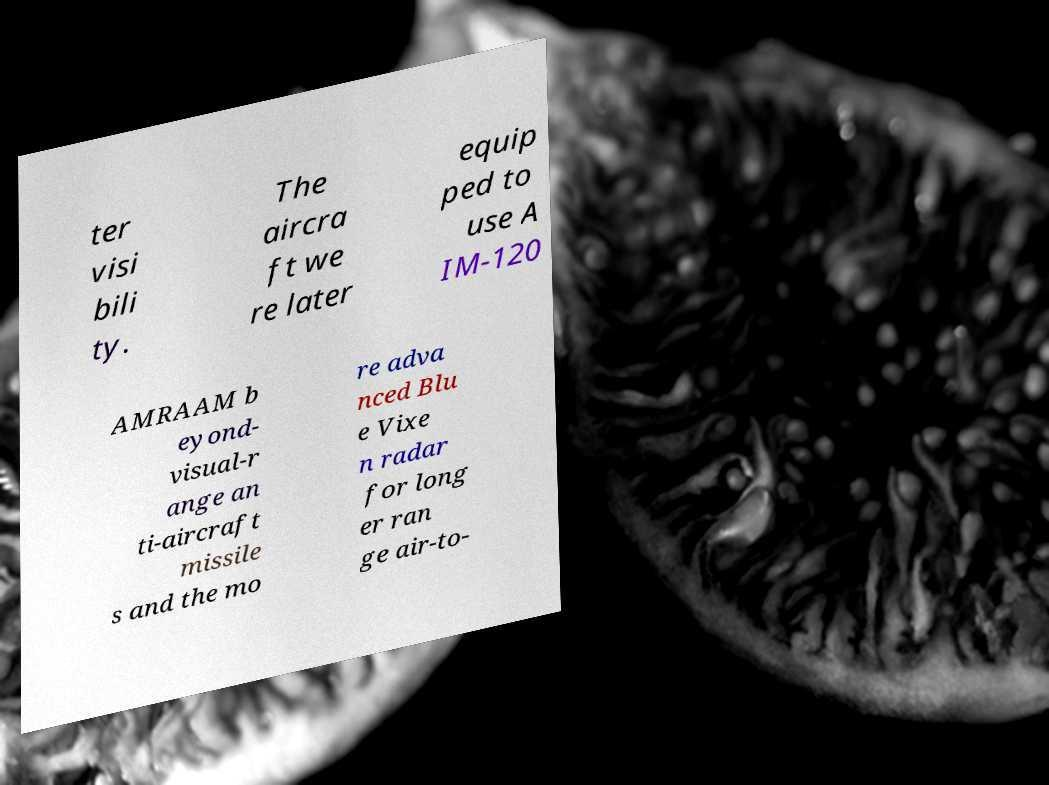There's text embedded in this image that I need extracted. Can you transcribe it verbatim? ter visi bili ty. The aircra ft we re later equip ped to use A IM-120 AMRAAM b eyond- visual-r ange an ti-aircraft missile s and the mo re adva nced Blu e Vixe n radar for long er ran ge air-to- 